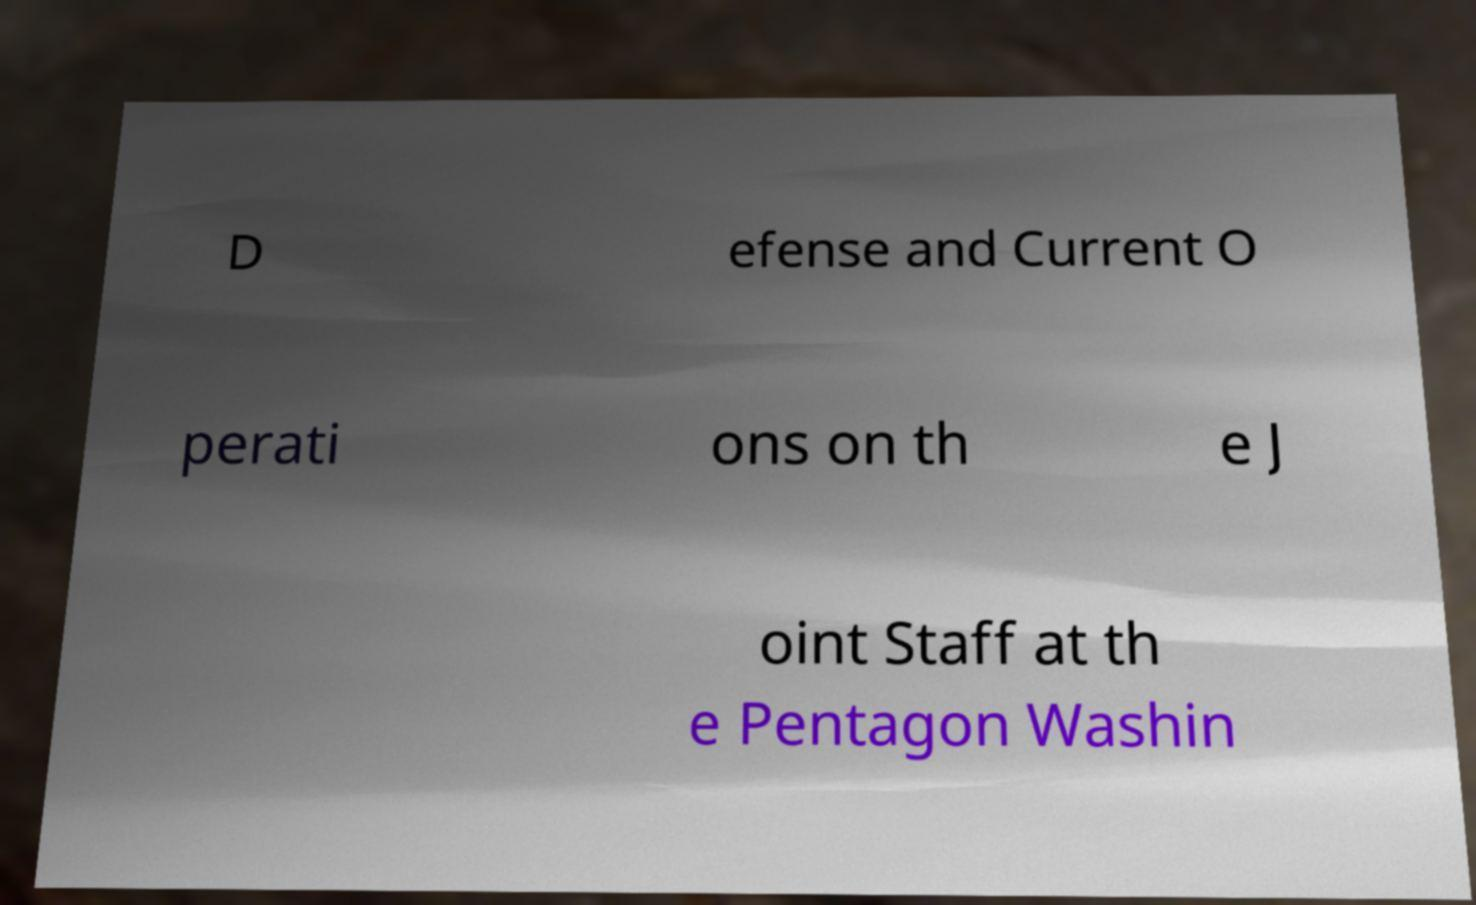Could you extract and type out the text from this image? D efense and Current O perati ons on th e J oint Staff at th e Pentagon Washin 